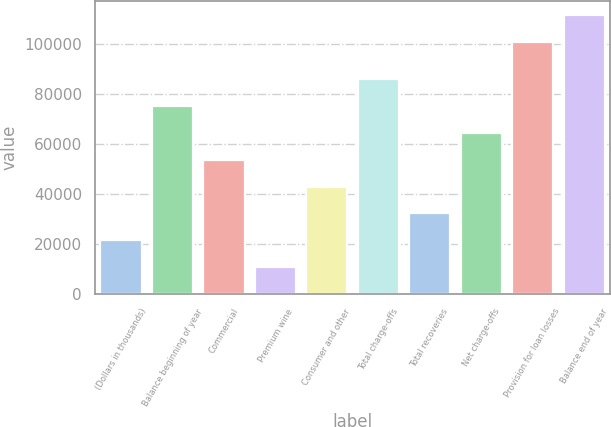Convert chart. <chart><loc_0><loc_0><loc_500><loc_500><bar_chart><fcel>(Dollars in thousands)<fcel>Balance beginning of year<fcel>Commercial<fcel>Premium wine<fcel>Consumer and other<fcel>Total charge-offs<fcel>Total recoveries<fcel>Net charge-offs<fcel>Provision for loan losses<fcel>Balance end of year<nl><fcel>21479.9<fcel>75177.4<fcel>53698.4<fcel>10740.4<fcel>42958.9<fcel>85916.9<fcel>32219.4<fcel>64437.9<fcel>100713<fcel>111453<nl></chart> 